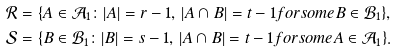Convert formula to latex. <formula><loc_0><loc_0><loc_500><loc_500>\mathcal { R } & = \{ A \in \mathcal { A } _ { 1 } \colon | A | = r - 1 , \, | A \cap B | = t - 1 f o r s o m e B \in \mathcal { B } _ { 1 } \} , \\ \mathcal { S } & = \{ B \in \mathcal { B } _ { 1 } \colon | B | = s - 1 , \, | A \cap B | = t - 1 f o r s o m e A \in \mathcal { A } _ { 1 } \} .</formula> 